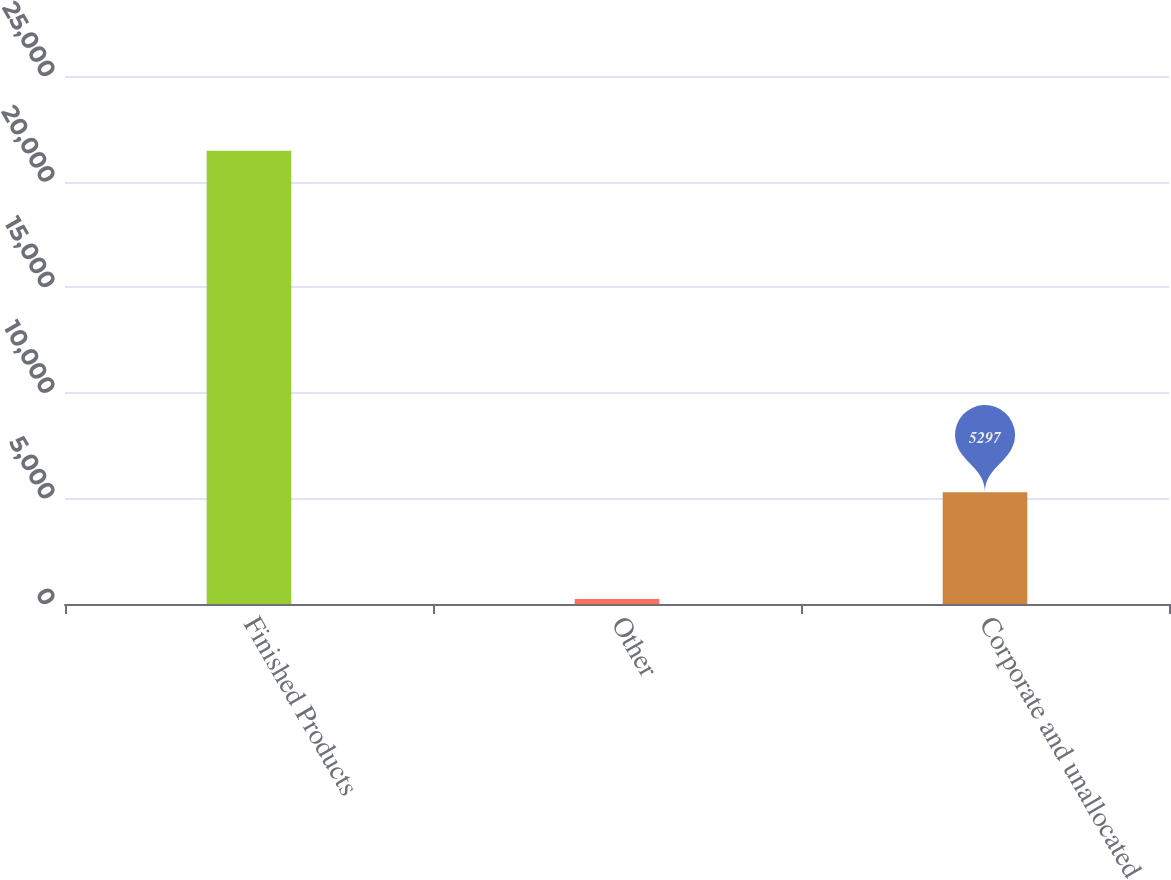Convert chart to OTSL. <chart><loc_0><loc_0><loc_500><loc_500><bar_chart><fcel>Finished Products<fcel>Other<fcel>Corporate and unallocated<nl><fcel>21464<fcel>231<fcel>5297<nl></chart> 